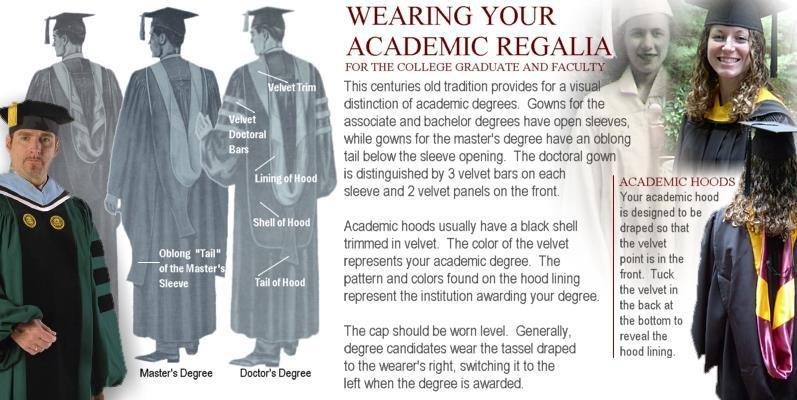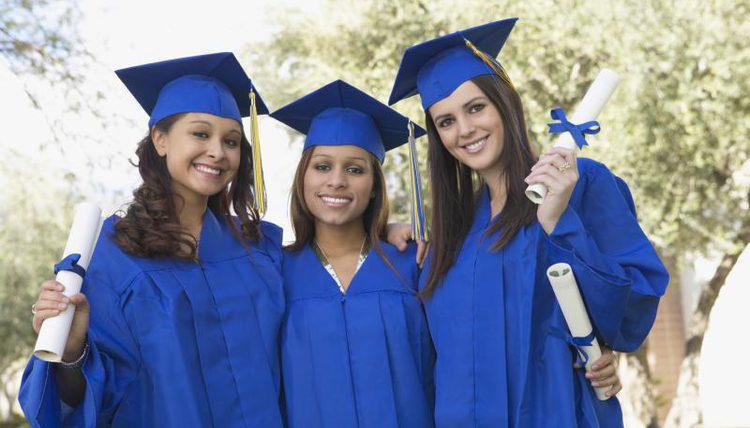The first image is the image on the left, the second image is the image on the right. For the images shown, is this caption "The full lengths of all graduation gowns are shown." true? Answer yes or no. No. 